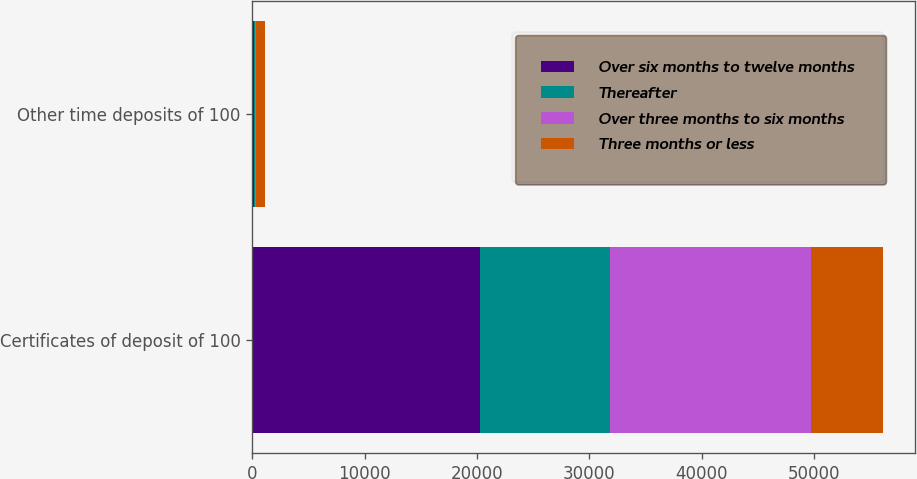Convert chart. <chart><loc_0><loc_0><loc_500><loc_500><stacked_bar_chart><ecel><fcel>Certificates of deposit of 100<fcel>Other time deposits of 100<nl><fcel>Over six months to twelve months<fcel>20253<fcel>154<nl><fcel>Thereafter<fcel>11588<fcel>117<nl><fcel>Over three months to six months<fcel>17904<fcel>96<nl><fcel>Three months or less<fcel>6410<fcel>758<nl></chart> 